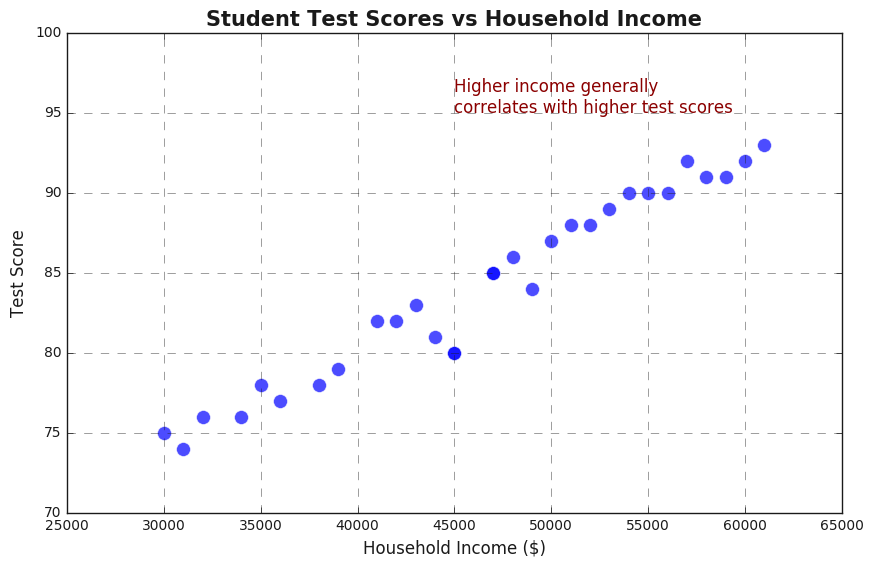Which income level has the highest test score? Find the highest test score on the y-axis and trace it horizontally to the corresponding income level on the x-axis.
Answer: $61,000 Is there a general trend between household income and test scores? Observe the overall pattern of the scatter plot. The points tend to move upward as household income increases, indicating a positive correlation.
Answer: Yes, higher household income generally correlates with higher test scores What is the test score for a household income of $35,000? Locate $35,000 on the x-axis and trace vertically until you intersect the corresponding data point on the scatter plot. The y-coordinate of this point is the test score.
Answer: 78 Compare the test scores of households with incomes of $30,000 and $60,000. Identify the points for $30,000 and $60,000 on the x-axis and compare their y-values (test scores).
Answer: Test scores are 75 and 92, respectively. $60,000 income has a higher score Estimate the average test score for household incomes around $50,000. Locate data points close to $50,000 on the x-axis and average their y-values. Data points include (47,000, 85), (48,000, 86), (49,000, 84), (50,000, 87), (51,000, 88). Average = (85 + 86 + 84 + 87 + 88) / 5 = 86
Answer: 86 By how many points does the test score improve as household income increases from $30,000 to $60,000? Subtract the test score for $30,000 from the test score for $60,000 (92 - 75).
Answer: 17 points Does any household income level have more than one test score? Inspect the scatter plot to see if multiple points share the same x-coordinate (household income).
Answer: No Can you describe the cluster of points on the scatter plot? Look for areas where points are densely packed together. Most points cluster in the middle range of income (around $45,000 to $55,000) with test scores ranging from 80 to 90.
Answer: Middle income range ($45,000 to $55,000) with scores from 80 to 90 Identify the income level and test score for the outlier data point, if any. Identify any point significantly distant from the general trend or cluster. No unusual outliers are noticeable.
Answer: No noticeable outlier What is the approximate test score range for incomes between $40,000 and $50,000? Identify data points where x-values range from $40,000 to $50,000 and find the range of their y-values. The points are (40,000, 82), (43,000, 83), (45,000, 80), (47,000, 85), (48,000, 86). The range is [80, 86].
Answer: 80 to 86 